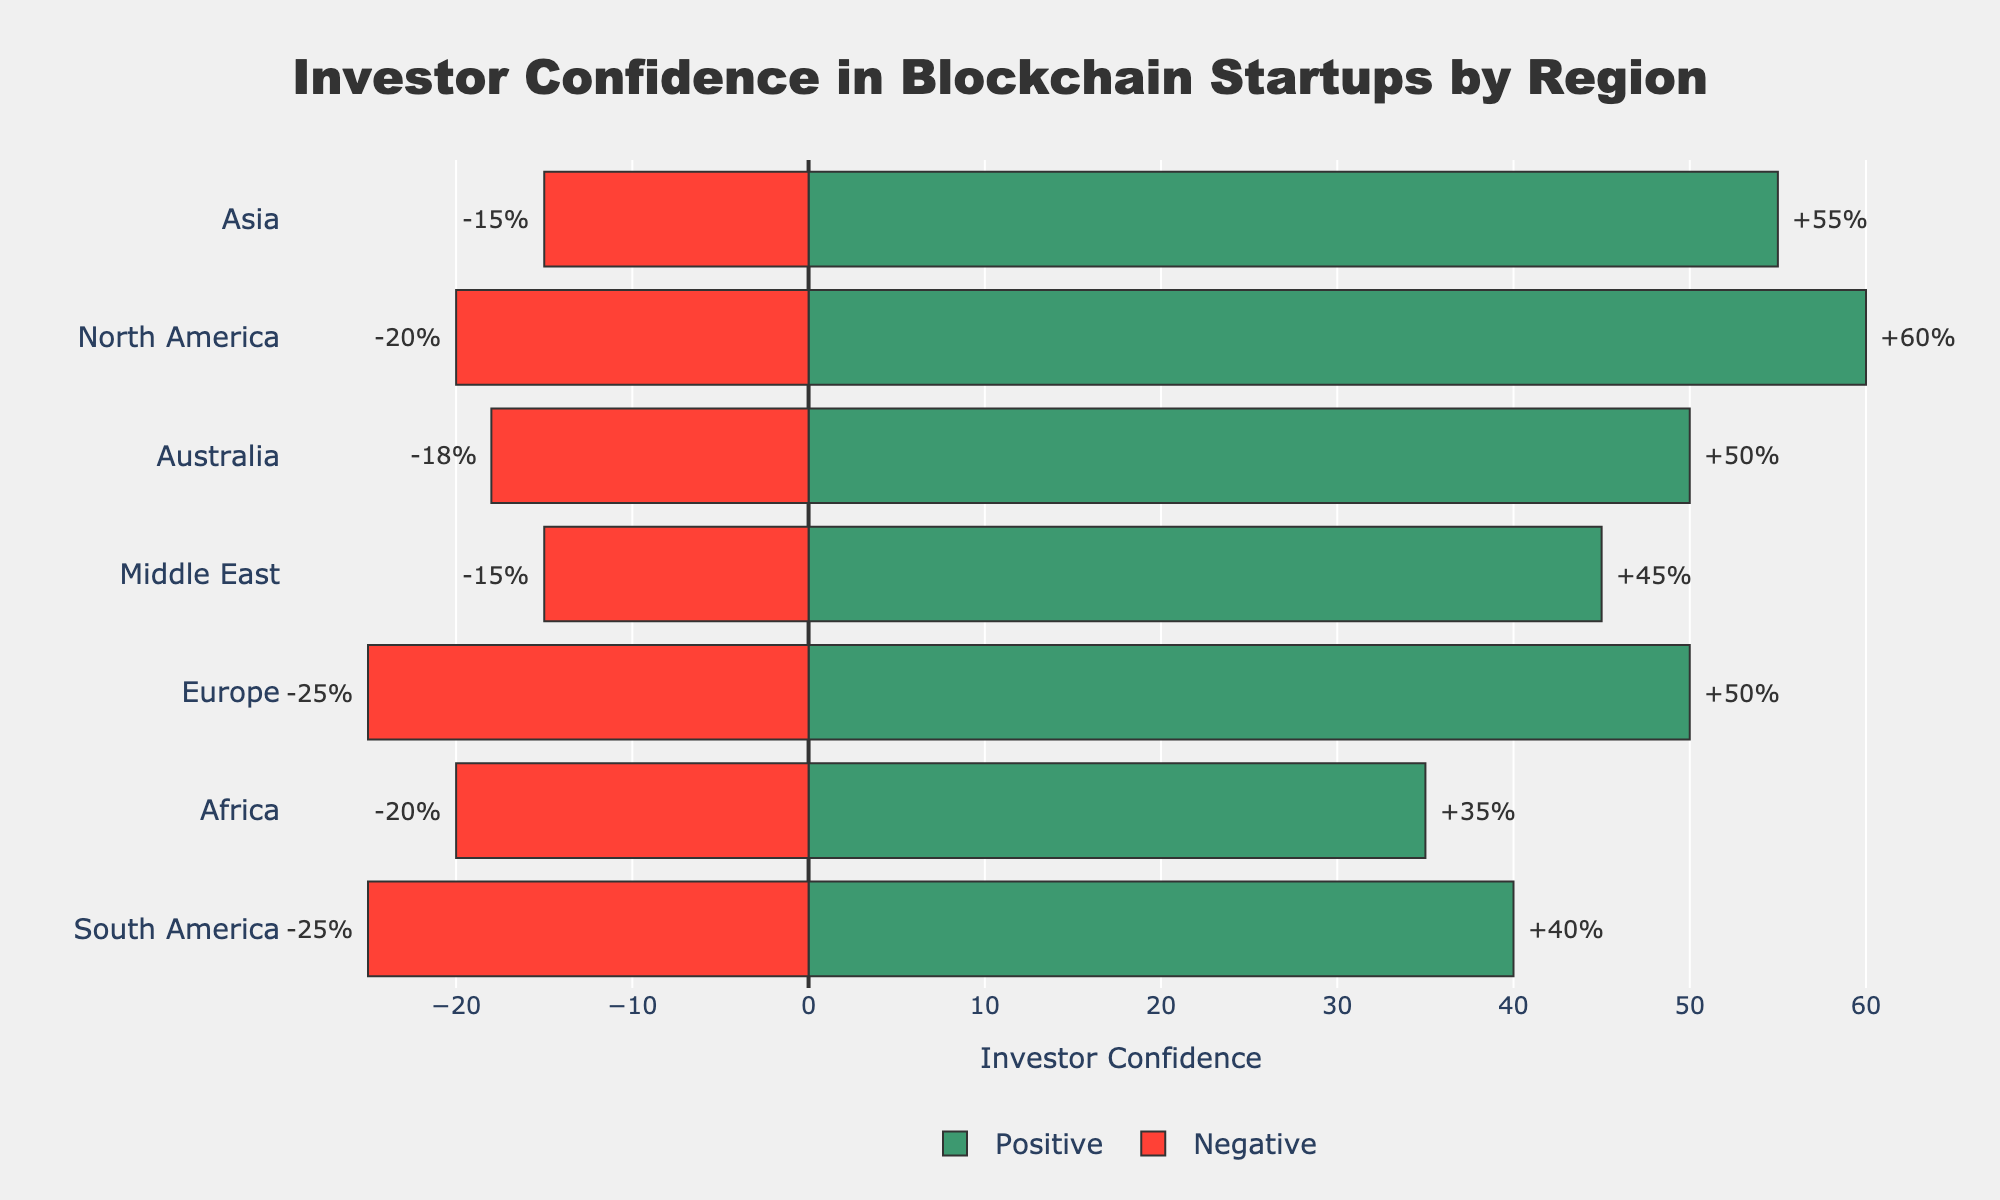what regions have a positive investor confidence greater than 50% and a negative investor confidence less than 20%? To find the regions matching these criteria, we look for bars indicating positive investor confidence greater than 50% (green bars longer than 50 on the x-axis) and negative investor confidence less than 20% (red bars shorter than 20 on the negative x-axis). North America, Asia, and the Middle East have positive greater than 50% (80%, 70%, and 60% respectively) and negative less than 20% (20%, 15%, and 15% respectively).
Answer: North America, Asia, Middle East which region has the highest positive investor confidence? By looking at the green bars' lengths, we find the highest bar. North America's green bar is the longest, reaching 80%.
Answer: North America what is the net investor confidence in Europe? Net investor confidence is calculated by subtracting negative confidence from positive confidence. For Europe, the positive confidence is 75% and the negative confidence is 25%. Therefore, net confidence is 75% - 25% = 50%.
Answer: 50% compare the net investor confidence between South America and Africa. Which one has higher net confidence? Calculating net confidence: South America has 40% positive - 25% negative = 15%. Africa has 35% positive - 20% negative = 15%. Both have the same net confidence.
Answer: Equal what’s the average positive investor confidence across all regions? Add the positive confidence percentages across all regions and divide by the number of regions: (60+50+55+40+35+45+50)/7. Calculation: (80 + 75 + 70 + 65 + 55 + 60 + 68) / 7 = 67.57% (rounded to two decimal places).
Answer: 67.57% which regions have a net positive investor confidence? Regions with positive investor confidence larger than negative confidence will have net positive confidence. Checking each region: North America (80% - 20% = 60%), Europe (75% - 25% = 50%), Asia (70% - 15% = 55%), South America (65% - 25% = 40%), Africa (55% - 20% = 35%), Middle East (60% - 15% = 45%), and Australia (68% - 18% = 50%). All regions have net positive confidence.
Answer: All regions 